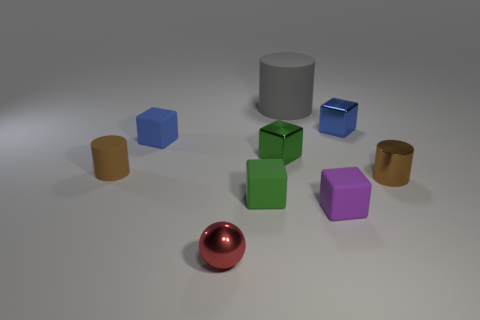Are the small blue object in front of the blue shiny object and the red thing made of the same material? Based on the image, the small blue object and the red thing appear to have different textures and light reflections, suggesting that they are not made of the same material. The blue object has a matte finish, while the red object has a metallic, reflective surface. 